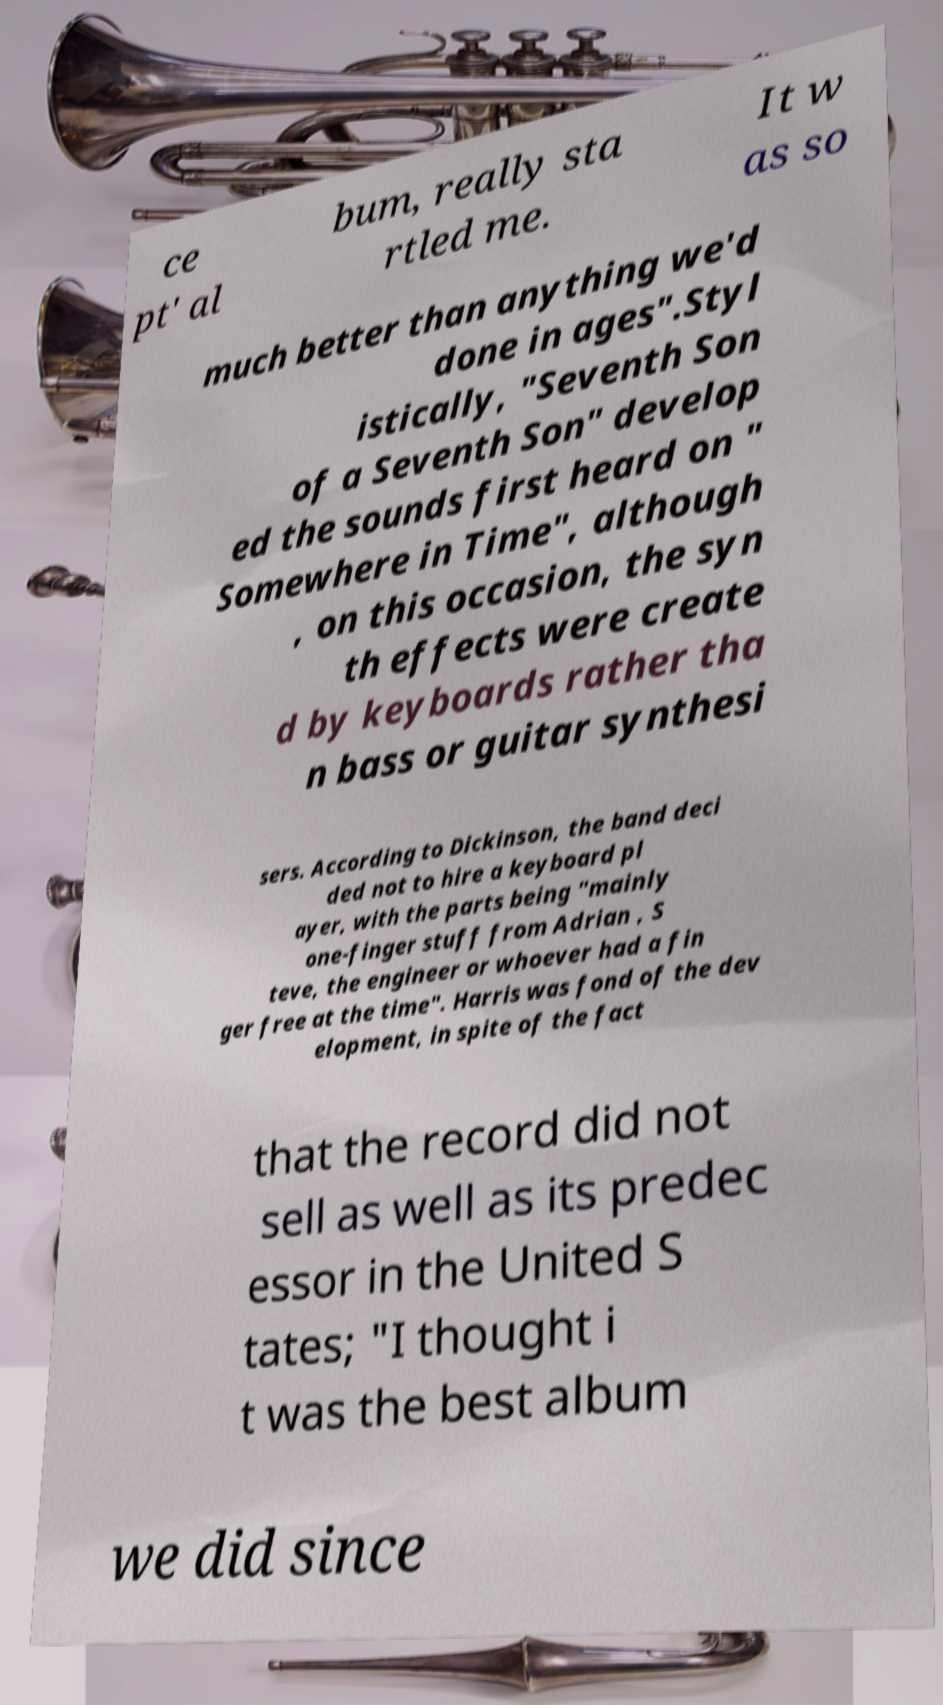I need the written content from this picture converted into text. Can you do that? ce pt' al bum, really sta rtled me. It w as so much better than anything we'd done in ages".Styl istically, "Seventh Son of a Seventh Son" develop ed the sounds first heard on " Somewhere in Time", although , on this occasion, the syn th effects were create d by keyboards rather tha n bass or guitar synthesi sers. According to Dickinson, the band deci ded not to hire a keyboard pl ayer, with the parts being "mainly one-finger stuff from Adrian , S teve, the engineer or whoever had a fin ger free at the time". Harris was fond of the dev elopment, in spite of the fact that the record did not sell as well as its predec essor in the United S tates; "I thought i t was the best album we did since 